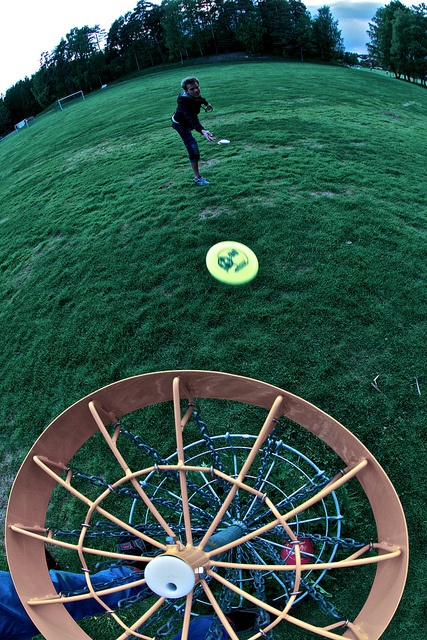Describe the objects in this image and their specific colors. I can see people in white, navy, black, salmon, and gray tones, people in white, black, navy, teal, and blue tones, frisbee in white, lightgreen, and lightyellow tones, and frisbee in white, lightblue, and blue tones in this image. 